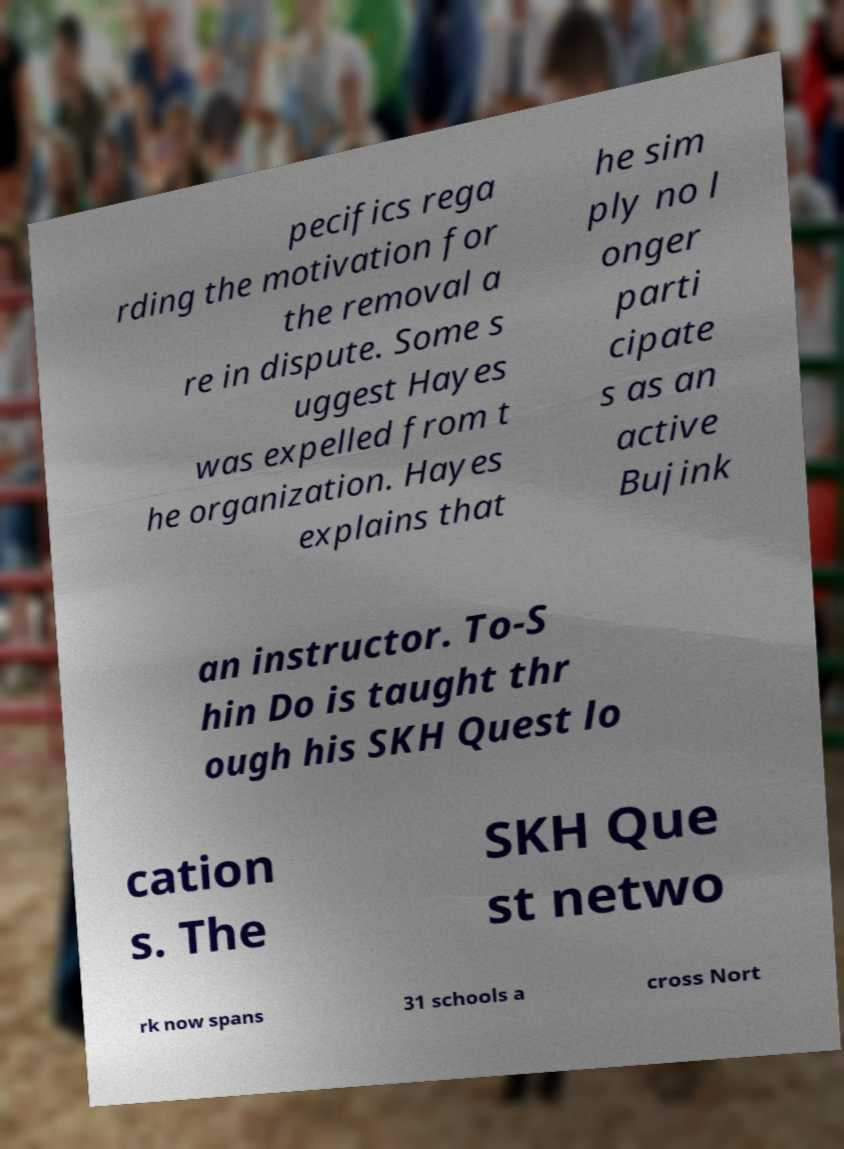What messages or text are displayed in this image? I need them in a readable, typed format. pecifics rega rding the motivation for the removal a re in dispute. Some s uggest Hayes was expelled from t he organization. Hayes explains that he sim ply no l onger parti cipate s as an active Bujink an instructor. To-S hin Do is taught thr ough his SKH Quest lo cation s. The SKH Que st netwo rk now spans 31 schools a cross Nort 